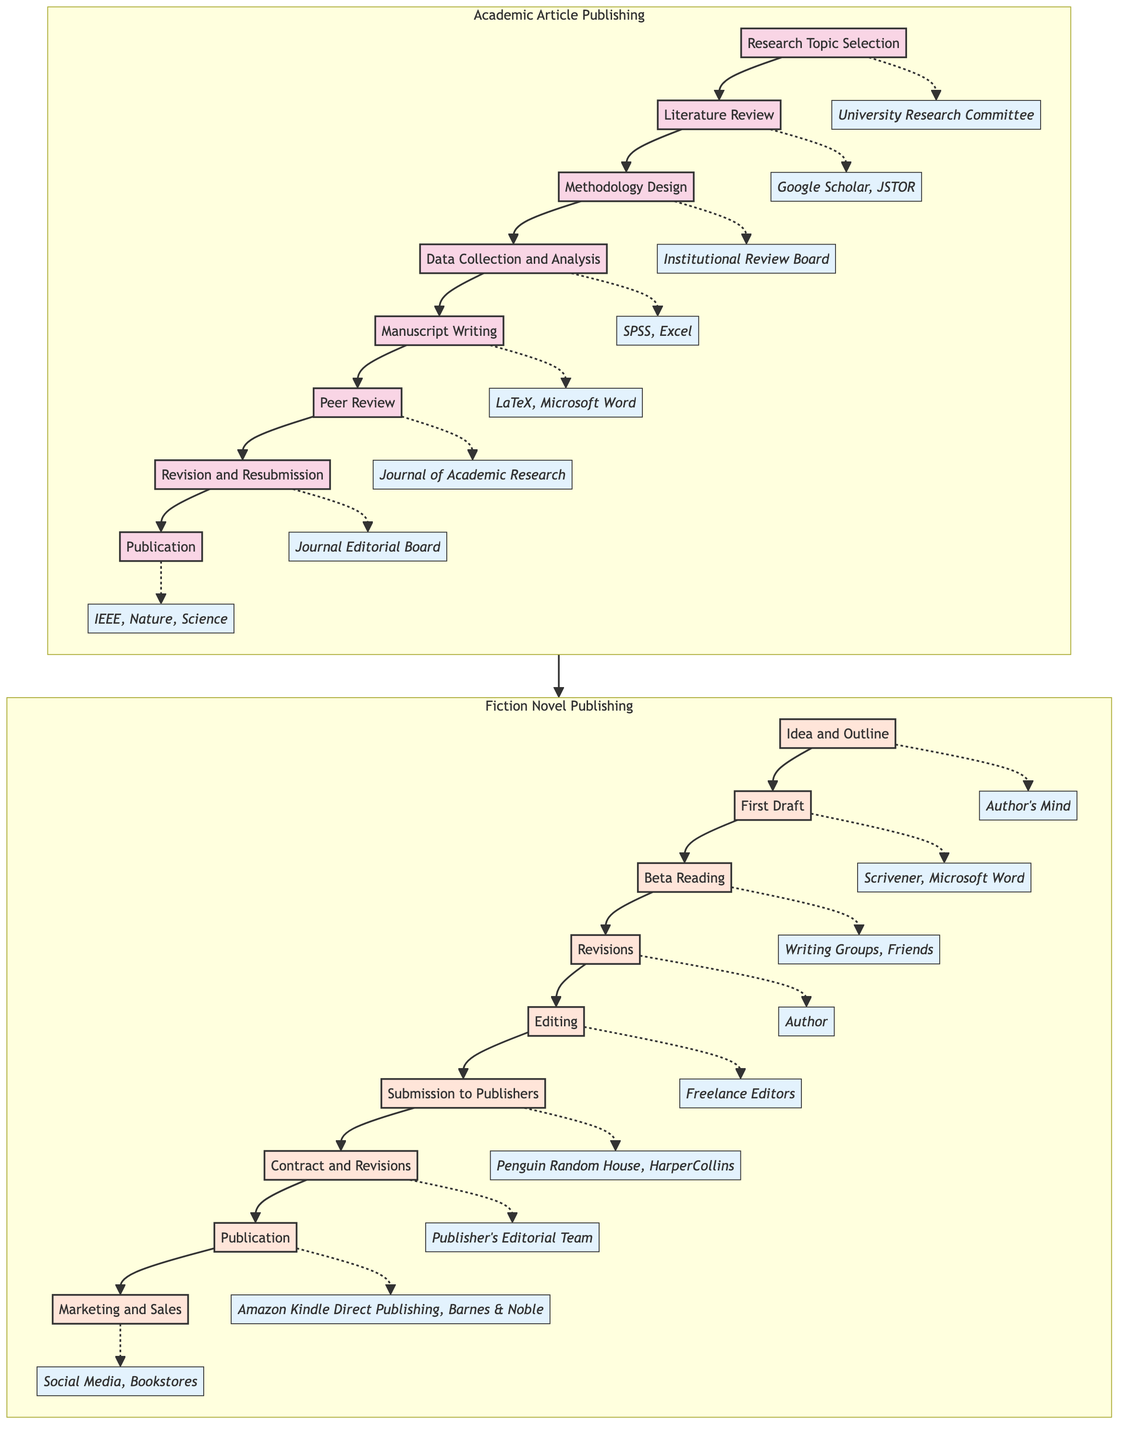What is the first step in publishing an academic article? The first step is represented by the node labeled "Research Topic Selection," which is the starting point of the flowchart for academic articles.
Answer: Research Topic Selection How many steps are there in the process of publishing a fiction novel? The flowchart outlines a total of nine distinct steps, starting from "Idea and Outline" and ending at "Marketing and Sales."
Answer: Nine What entity is associated with the "Peer Review" step in academic articles? The "Peer Review" step is linked to the entity "Journal of Academic Research," which indicates where the manuscript is submitted for review.
Answer: Journal of Academic Research In the fiction novel publishing process, what comes immediately after the "First Draft"? Following the "First Draft," the next step is "Beta Reading," where the draft is shared for initial feedback.
Answer: Beta Reading Which step in the academic article publishing process involves collecting and analyzing data? The step focused on collecting and analyzing data is labeled "Data Collection and Analysis," which is essential for the research methodology.
Answer: Data Collection and Analysis What is the last step for publishing fiction novels? The final step represented in the fiction novel process is "Marketing and Sales," highlighting the importance of promoting the book post-publication.
Answer: Marketing and Sales How does the "Revision and Resubmission" step fit into the academic article flow? "Revision and Resubmission" follows "Peer Review," indicating that feedback from reviewers must be incorporated before final acceptance for publication.
Answer: After Peer Review What is the primary entity involved in the "Editing" phase of a fiction novel? The "Editing" stage specifically calls for "Freelance Editors," reflecting the need for professional expertise in refining the manuscript.
Answer: Freelance Editors How are the steps in both publishing processes linked? The arrow connection between the Academic and Fiction subgraphs illustrates that while the processes are distinct, they are both paths leading to the final goal of publishing.
Answer: Connected processes 